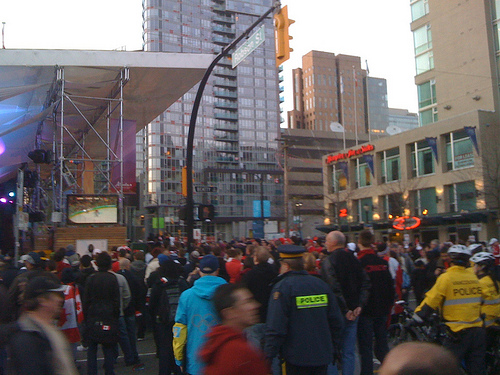<image>
Is the signal above the policeman? Yes. The signal is positioned above the policeman in the vertical space, higher up in the scene. 